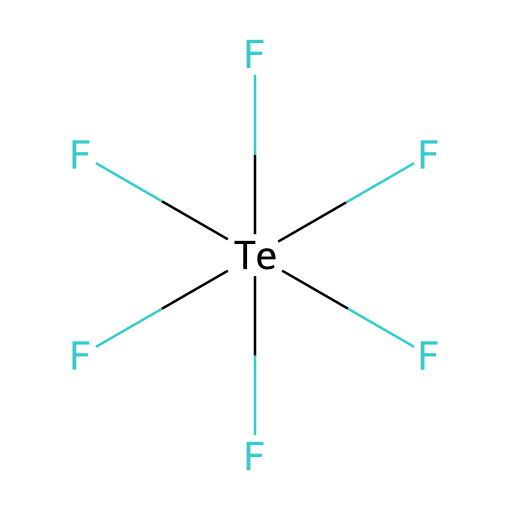How many fluorine atoms are present in the compound? The structure contains the notation 'F' repeated six times, indicating six fluorine atoms bonded to the tellurium atom.
Answer: six What is the central atom in tellurium hexafluoride? The central atom can be identified as 'Te', which is represented in the chemical structure and is surrounded by the fluorine atoms.
Answer: tellurium What is the hybridization of the central atom in this compound? In tellurium hexafluoride, the central tellurium atom forms six bonds with the fluorine atoms, leading to sp3d2 hybridization, which accommodates the additional bonding partners.
Answer: sp3d2 What type of bond exists between tellurium and fluorine? The bonds between tellurium and fluorine in tellurium hexafluoride are covalent bonds, as indicated by the pairing of the central atom with fluoride atoms.
Answer: covalent Why is tellurium hexafluoride considered a hypervalent compound? Hypervalent compounds are characterized by a central atom that can have more than eight electrons in its valence shell. In this case, tellurium has twelve electrons shared with six fluorine atoms, exceeding the octet rule.
Answer: hypervalent What is the molecular geometry of tellurium hexafluoride? The molecular geometry can be deduced from the six surrounding fluorine atoms and the central tellurium atom, resulting in an octahedral shape due to the symmetrical arrangement of the bonding pairs.
Answer: octahedral 